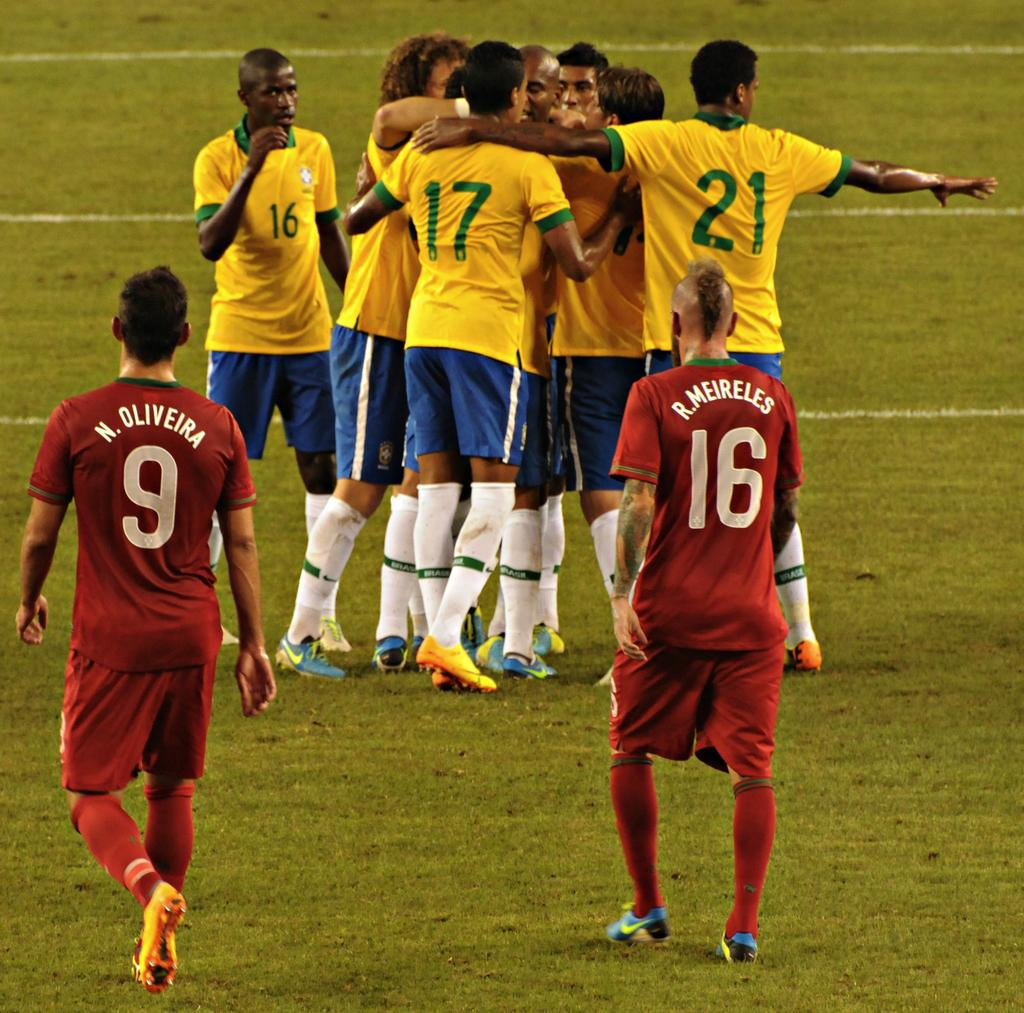<image>
Offer a succinct explanation of the picture presented. Two players in red, with N. Oliverira 9 and R. Meireles 16 on their jerseys face a group of players in yellow shirts. 